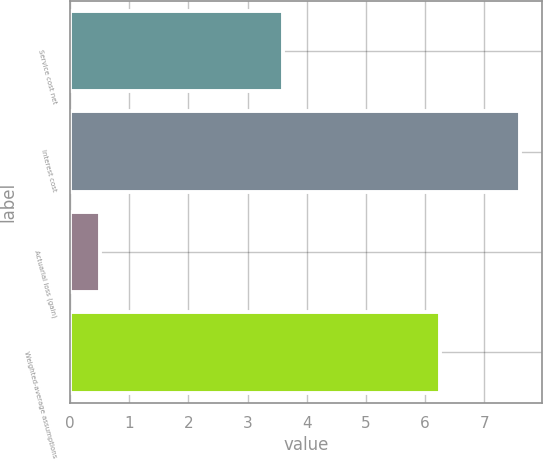<chart> <loc_0><loc_0><loc_500><loc_500><bar_chart><fcel>Service cost net<fcel>Interest cost<fcel>Actuarial loss (gain)<fcel>Weighted-average assumptions<nl><fcel>3.6<fcel>7.6<fcel>0.5<fcel>6.25<nl></chart> 